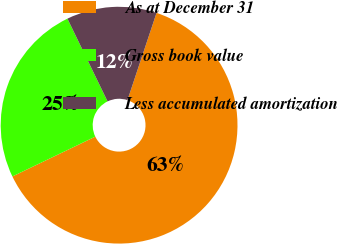Convert chart to OTSL. <chart><loc_0><loc_0><loc_500><loc_500><pie_chart><fcel>As at December 31<fcel>Gross book value<fcel>Less accumulated amortization<nl><fcel>62.75%<fcel>24.94%<fcel>12.31%<nl></chart> 